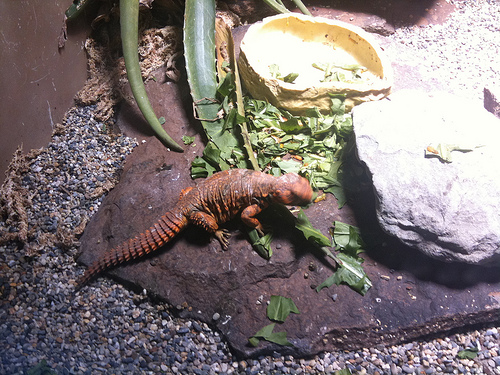<image>
Is there a lizard on the rock? Yes. Looking at the image, I can see the lizard is positioned on top of the rock, with the rock providing support. 